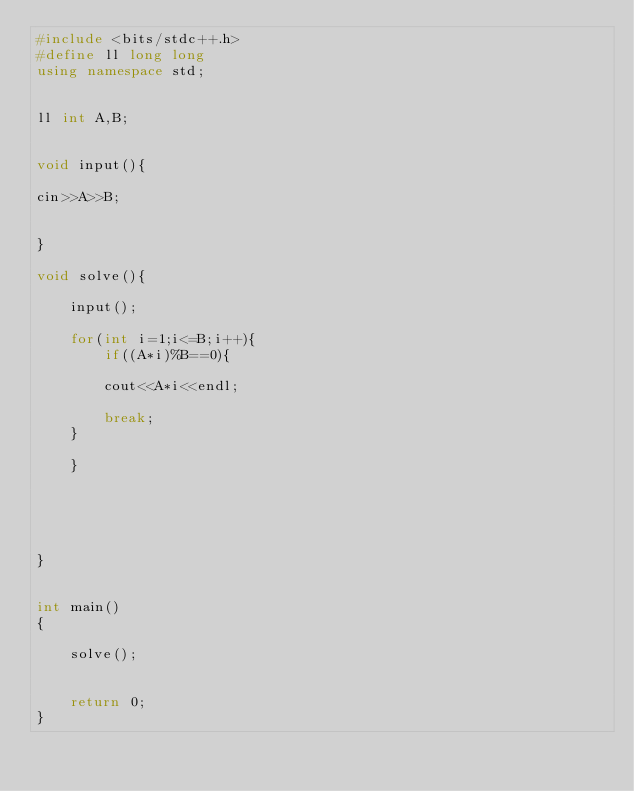<code> <loc_0><loc_0><loc_500><loc_500><_C++_>#include <bits/stdc++.h>
#define ll long long
using namespace std;


ll int A,B;


void input(){

cin>>A>>B;


}

void solve(){

    input();

    for(int i=1;i<=B;i++){
        if((A*i)%B==0){

        cout<<A*i<<endl;

        break;
    }

    }





}


int main()
{

    solve();


    return 0;
}

</code> 